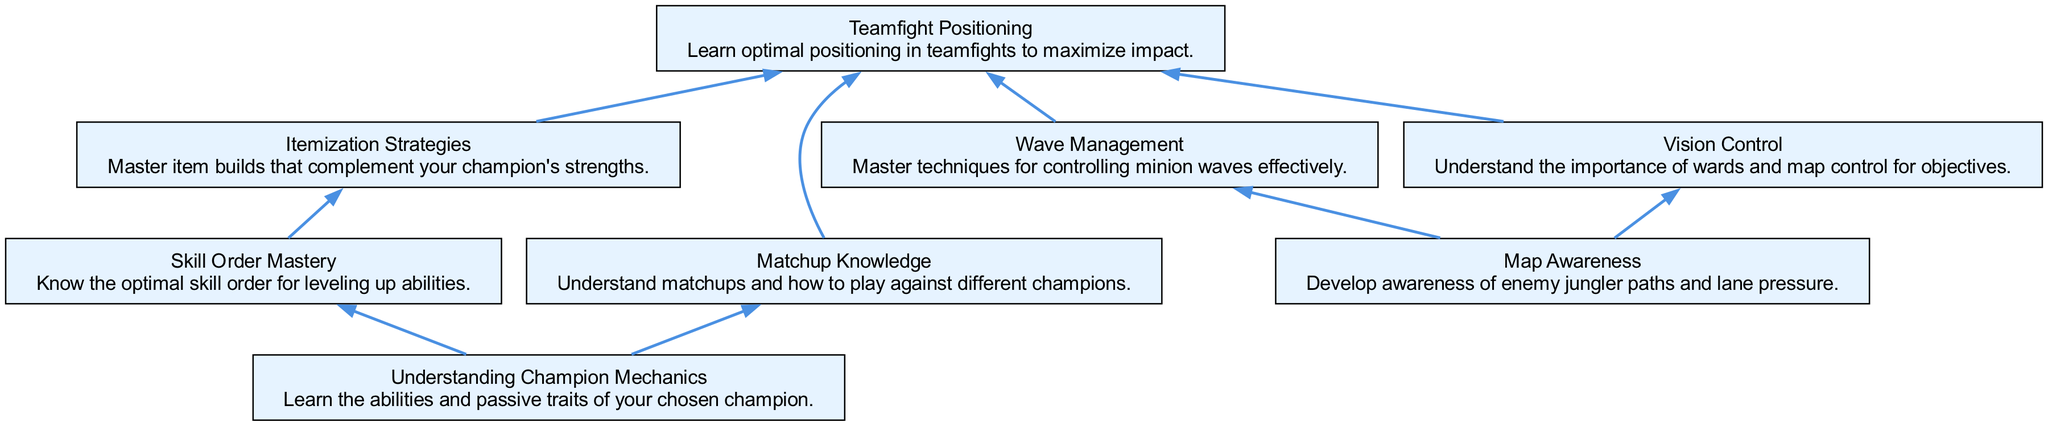What is the topmost node in the diagram? The topmost node is "Understanding Champion Mechanics," as it is positioned at the very top of the flow chart.
Answer: Understanding Champion Mechanics How many nodes are present in the diagram? By counting the elements listed, there are a total of eight nodes representing different skills and strategies in champion mastery.
Answer: 8 Which node leads to both "Itemization Strategies" and "Teamfight Positioning"? The node "Skill Order Mastery" leads directly to "Itemization Strategies" and is also linked to "Teamfight Positioning."
Answer: Skill Order Mastery What skills are connected to "Map Awareness"? The skills "Vision Control" and "Wave Management" are both connected to "Map Awareness" as they are directly linked by edges to that node.
Answer: Vision Control, Wave Management How does "Matchup Knowledge" contribute to team performance? "Matchup Knowledge" connects to "Teamfight Positioning," indicating that knowledge of matchups helps improve positioning during teamfights, enhancing overall team performance.
Answer: Teamfight Positioning Which elements directly influence "Teamfight Positioning"? The elements that directly influence "Teamfight Positioning" are "Matchup Knowledge," "Itemization Strategies," "Wave Management," and "Vision Control," as all of these nodes point towards "Teamfight Positioning."
Answer: Matchup Knowledge, Itemization Strategies, Wave Management, Vision Control What is the relationship between "Wave Management" and "Teamfight Positioning"? "Wave Management" is linked directly to "Teamfight Positioning," indicating that how players manage minion waves is relevant to their positioning in teamfights.
Answer: Directly linked What are the two main branches stemming from the initial node? The two main branches from "Understanding Champion Mechanics" lead to "Skill Order Mastery" and "Matchup Knowledge," showing foundational skills for champion mastery.
Answer: Skill Order Mastery, Matchup Knowledge 